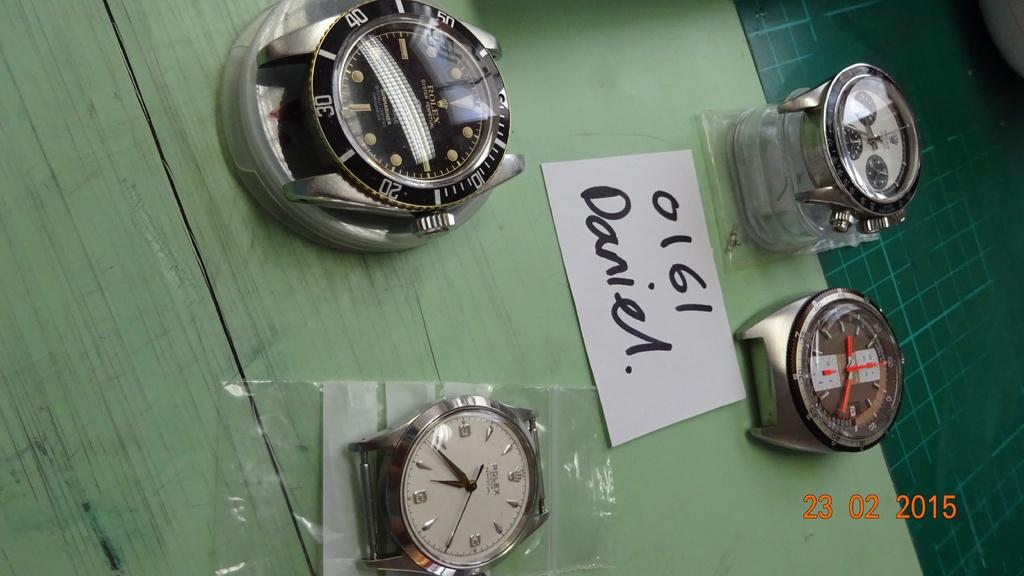What is the 4 digit number on the card?
Offer a very short reply. 0161. What name is on the card?
Keep it short and to the point. Daniel. 